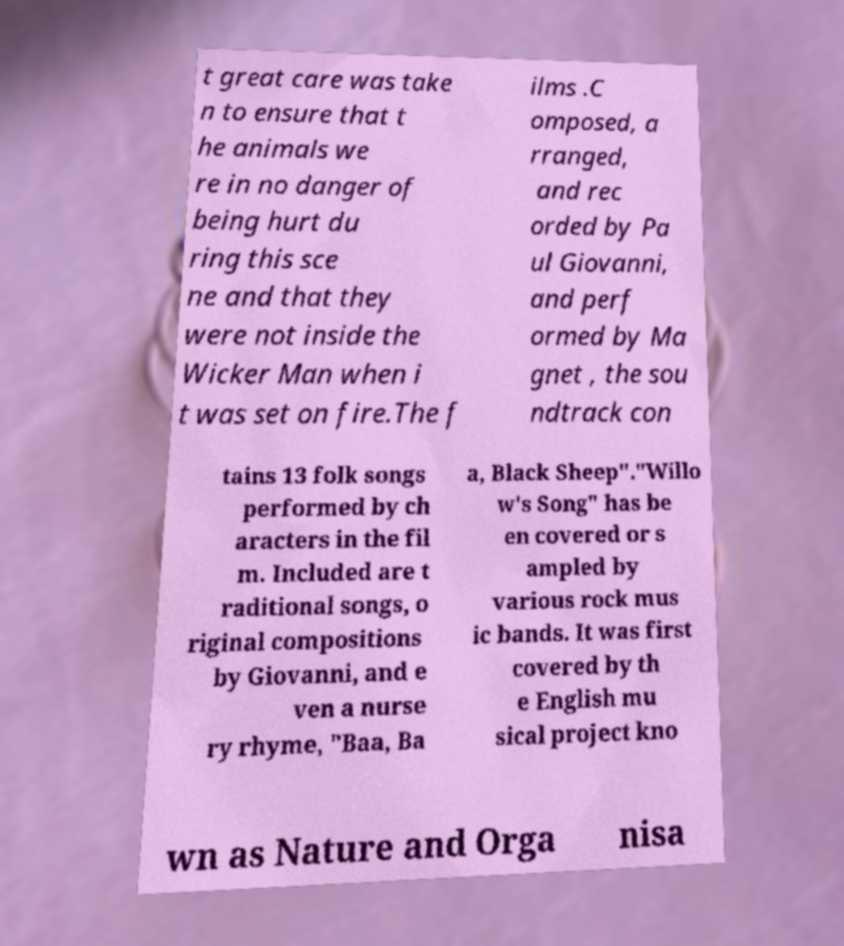What messages or text are displayed in this image? I need them in a readable, typed format. t great care was take n to ensure that t he animals we re in no danger of being hurt du ring this sce ne and that they were not inside the Wicker Man when i t was set on fire.The f ilms .C omposed, a rranged, and rec orded by Pa ul Giovanni, and perf ormed by Ma gnet , the sou ndtrack con tains 13 folk songs performed by ch aracters in the fil m. Included are t raditional songs, o riginal compositions by Giovanni, and e ven a nurse ry rhyme, "Baa, Ba a, Black Sheep"."Willo w's Song" has be en covered or s ampled by various rock mus ic bands. It was first covered by th e English mu sical project kno wn as Nature and Orga nisa 